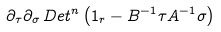Convert formula to latex. <formula><loc_0><loc_0><loc_500><loc_500>\partial _ { \tau } \partial _ { \sigma } \, D e t ^ { n } \left ( 1 _ { r } - B ^ { - 1 } \tau A ^ { - 1 } \sigma \right )</formula> 